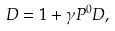<formula> <loc_0><loc_0><loc_500><loc_500>D = { 1 } + \gamma P ^ { 0 } D ,</formula> 